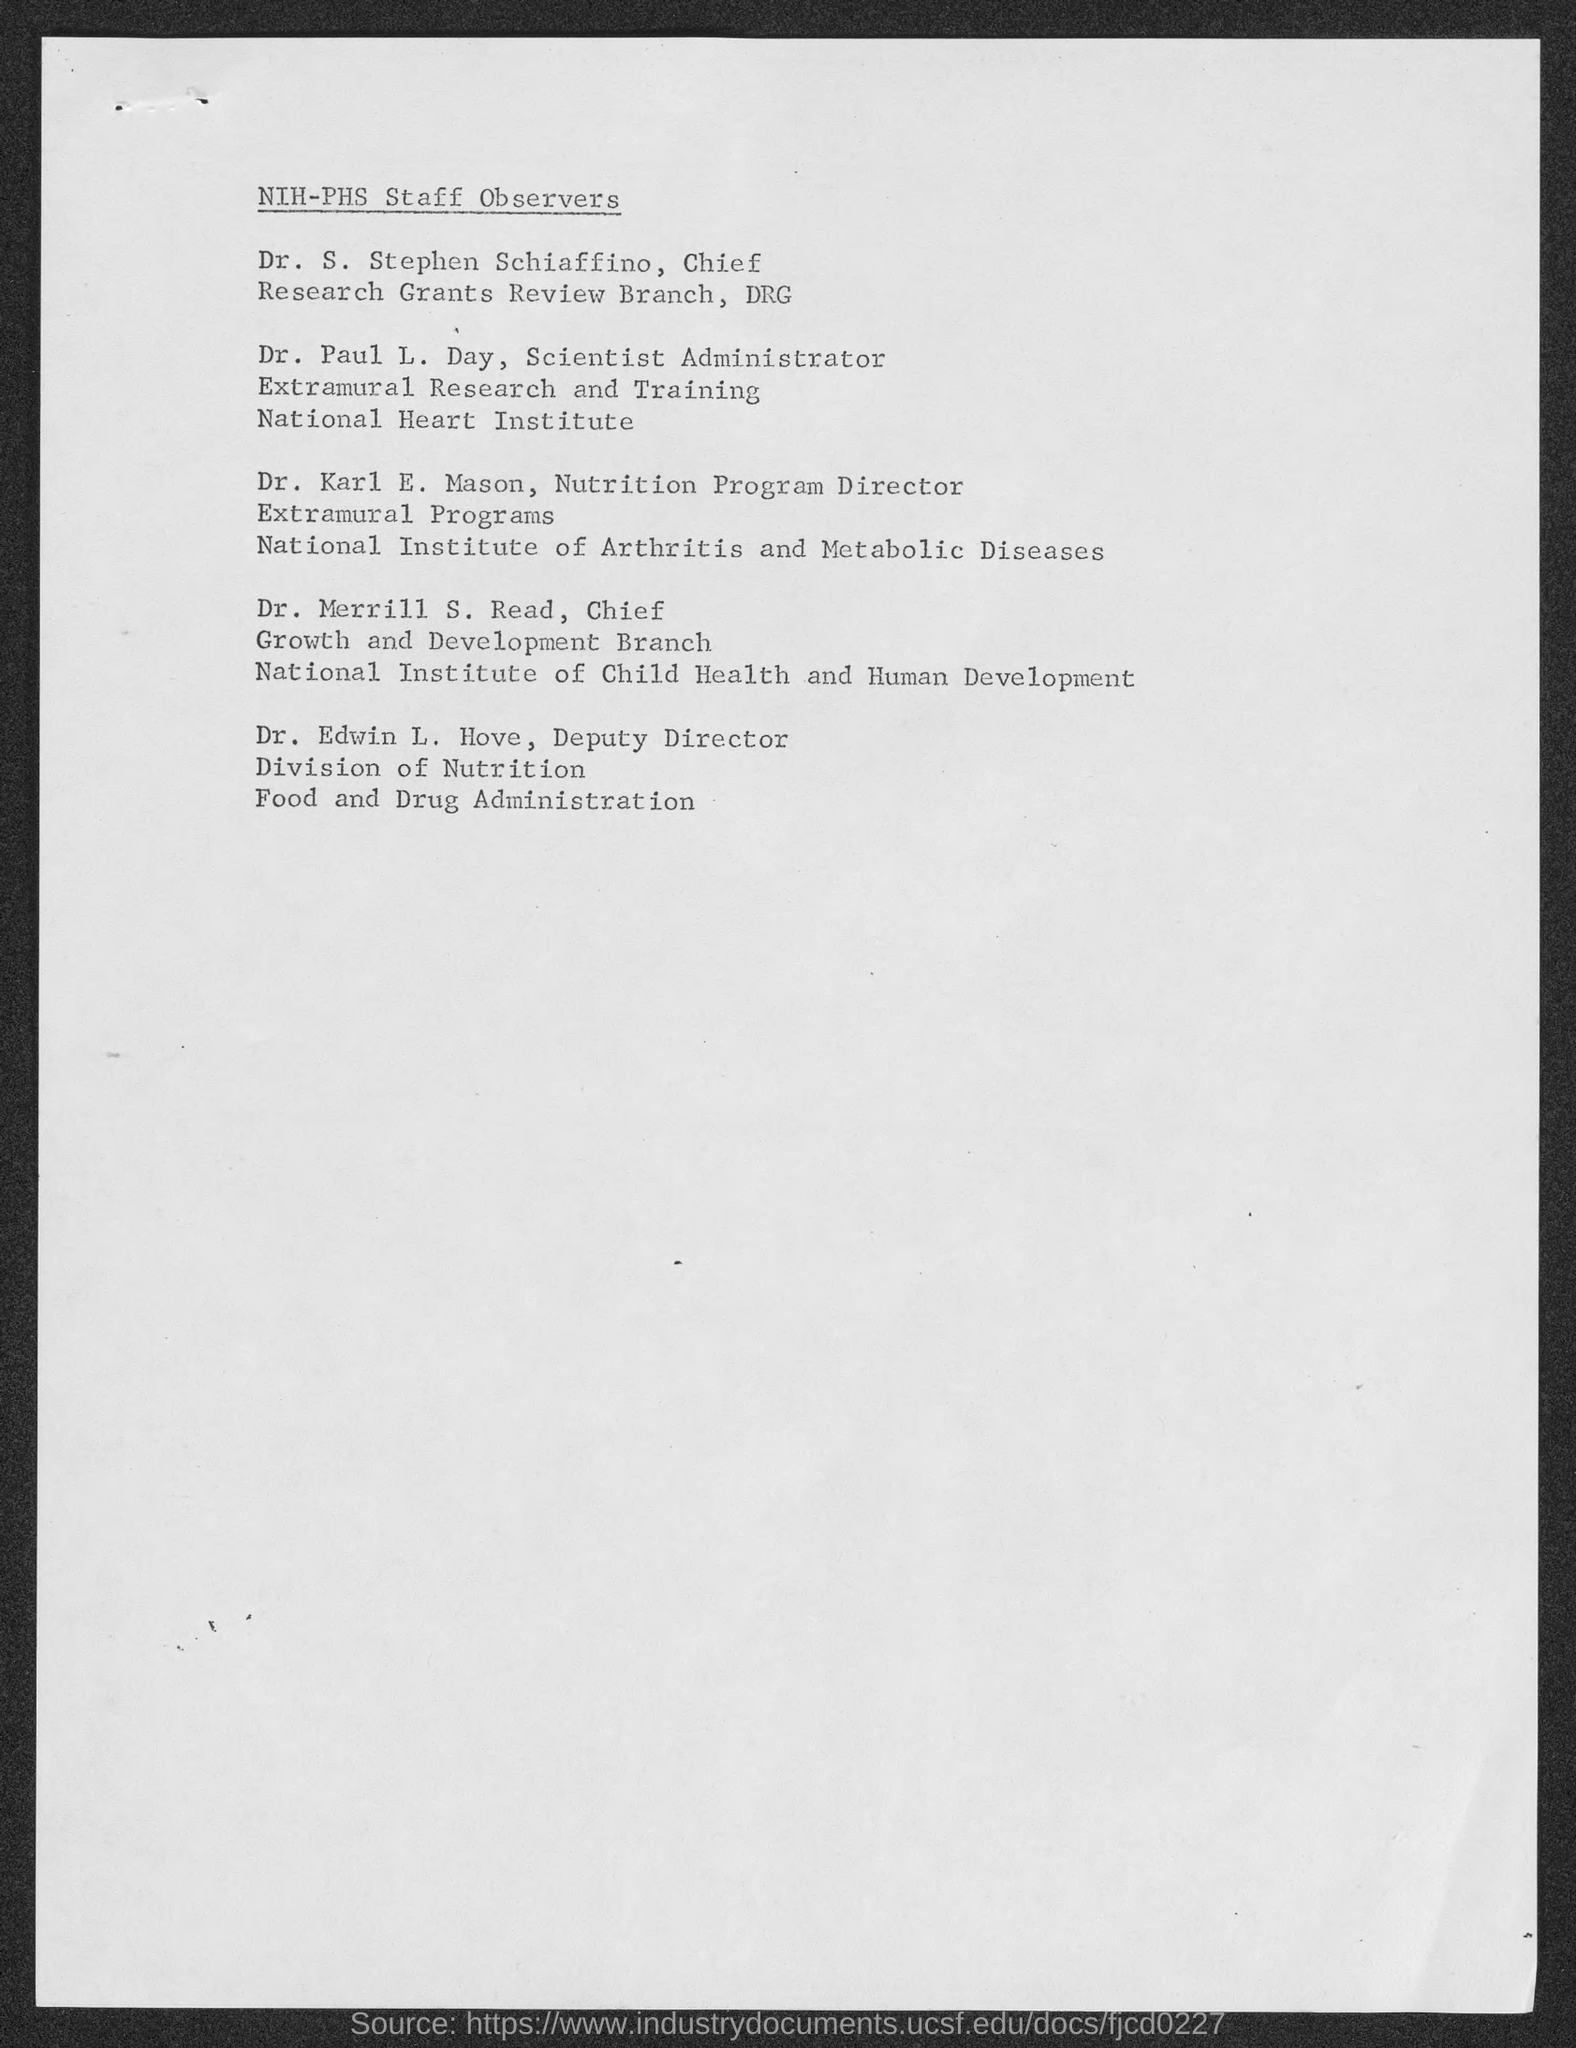Who is the Chief of Rsearch Grants Review Branch, DRG?
Your response must be concise. Dr. S. Stephen Schiaffino. Who is the Scientist Administrator, Extramural Research and Training?
Your response must be concise. Dr. Paul L. Day. What is the heading of this document?
Offer a very short reply. NIH-PHS Staff Observers. 